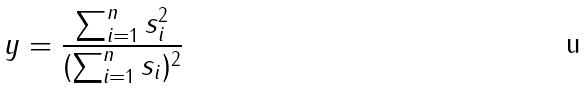Convert formula to latex. <formula><loc_0><loc_0><loc_500><loc_500>y = \frac { \sum _ { i = 1 } ^ { n } s _ { i } ^ { 2 } } { ( \sum _ { i = 1 } ^ { n } s _ { i } ) ^ { 2 } }</formula> 